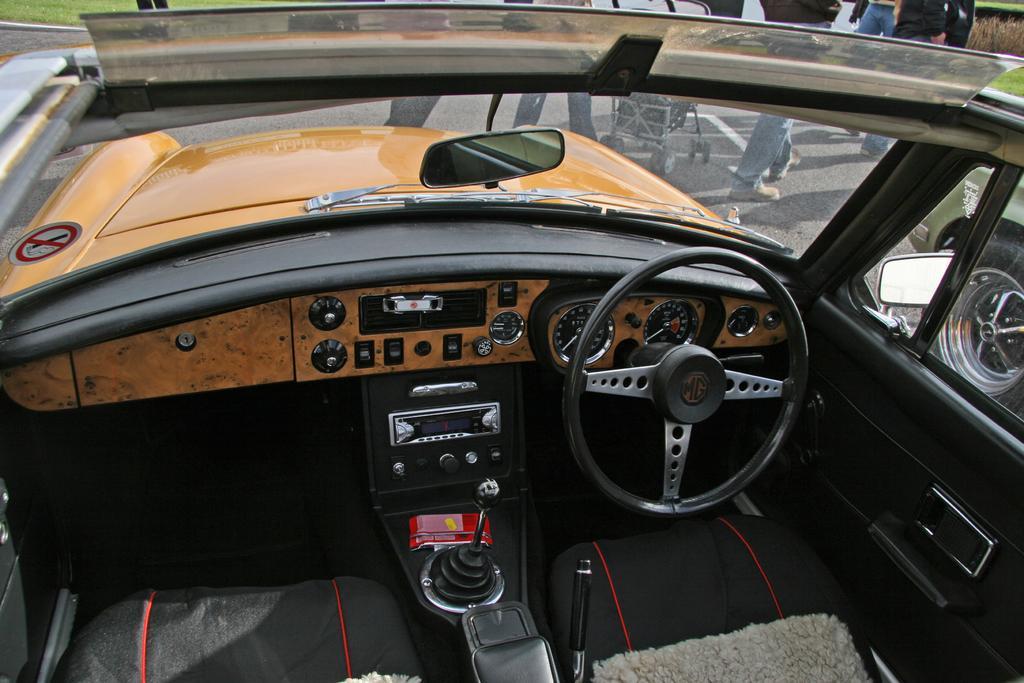Could you give a brief overview of what you see in this image? In this picture there is a vehicle in the foreground. At the back there are group of people walking and there is a person holding the baby traveler and walking. On the right side of the image there is a vehicle. At the bottom there is grass and there is a road. 